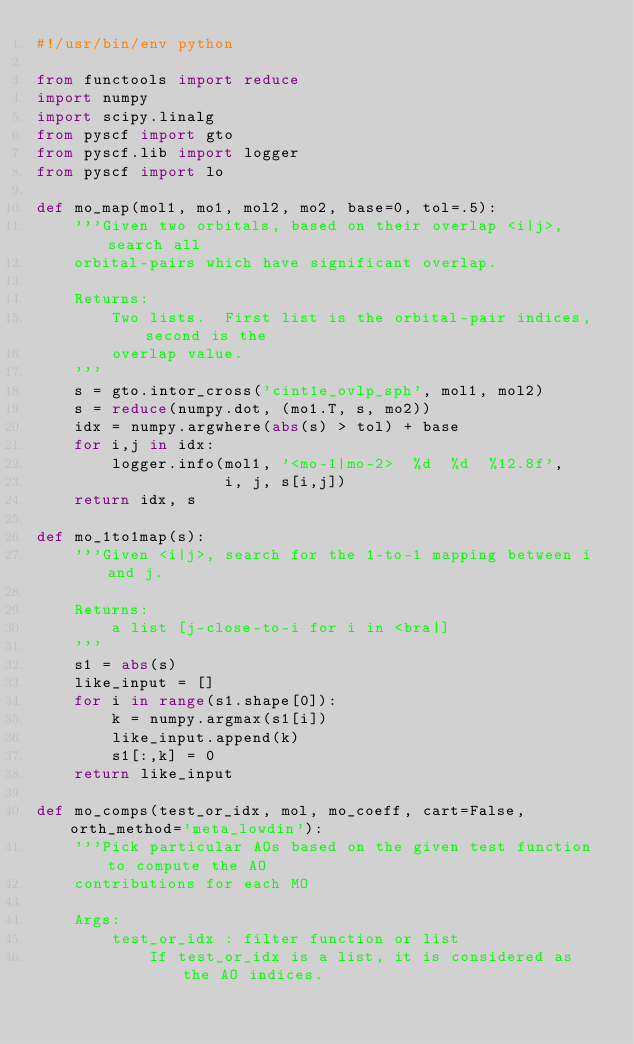<code> <loc_0><loc_0><loc_500><loc_500><_Python_>#!/usr/bin/env python

from functools import reduce
import numpy
import scipy.linalg
from pyscf import gto
from pyscf.lib import logger
from pyscf import lo

def mo_map(mol1, mo1, mol2, mo2, base=0, tol=.5):
    '''Given two orbitals, based on their overlap <i|j>, search all
    orbital-pairs which have significant overlap.

    Returns:
        Two lists.  First list is the orbital-pair indices, second is the
        overlap value.
    '''
    s = gto.intor_cross('cint1e_ovlp_sph', mol1, mol2)
    s = reduce(numpy.dot, (mo1.T, s, mo2))
    idx = numpy.argwhere(abs(s) > tol) + base
    for i,j in idx:
        logger.info(mol1, '<mo-1|mo-2>  %d  %d  %12.8f',
                    i, j, s[i,j])
    return idx, s

def mo_1to1map(s):
    '''Given <i|j>, search for the 1-to-1 mapping between i and j.

    Returns:
        a list [j-close-to-i for i in <bra|]
    '''
    s1 = abs(s)
    like_input = []
    for i in range(s1.shape[0]):
        k = numpy.argmax(s1[i])
        like_input.append(k)
        s1[:,k] = 0
    return like_input

def mo_comps(test_or_idx, mol, mo_coeff, cart=False, orth_method='meta_lowdin'):
    '''Pick particular AOs based on the given test function to compute the AO
    contributions for each MO

    Args:
        test_or_idx : filter function or list
            If test_or_idx is a list, it is considered as the AO indices.</code> 